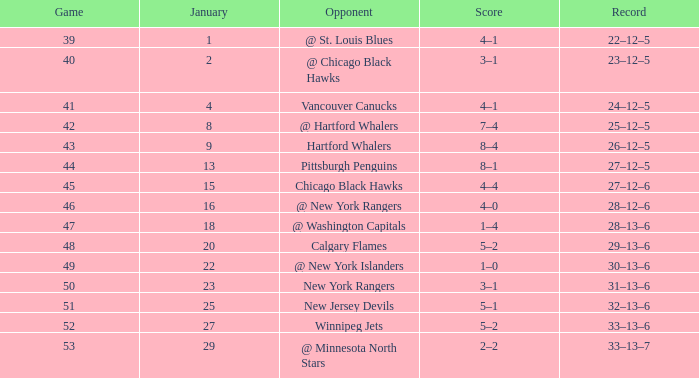Which Points have a Score of 4–1, and a Game smaller than 39? None. 